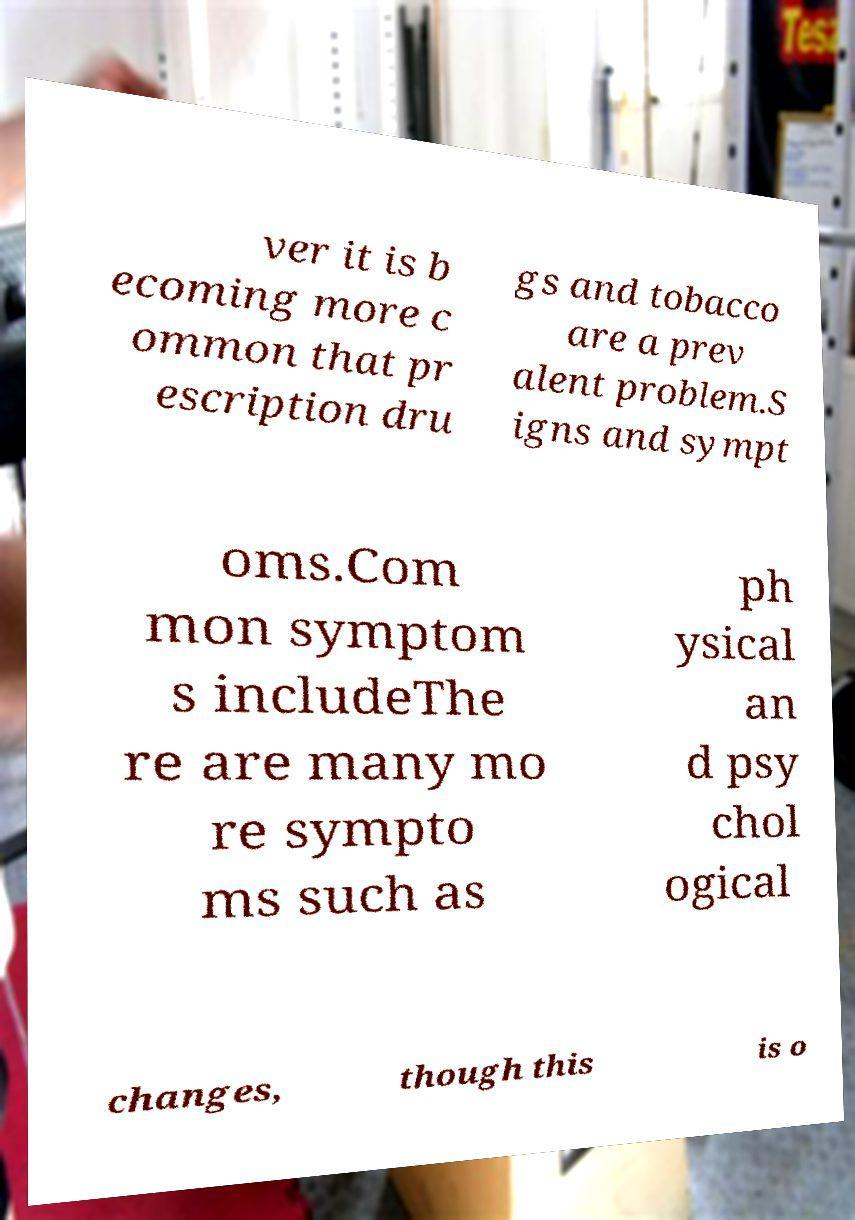Please read and relay the text visible in this image. What does it say? ver it is b ecoming more c ommon that pr escription dru gs and tobacco are a prev alent problem.S igns and sympt oms.Com mon symptom s includeThe re are many mo re sympto ms such as ph ysical an d psy chol ogical changes, though this is o 